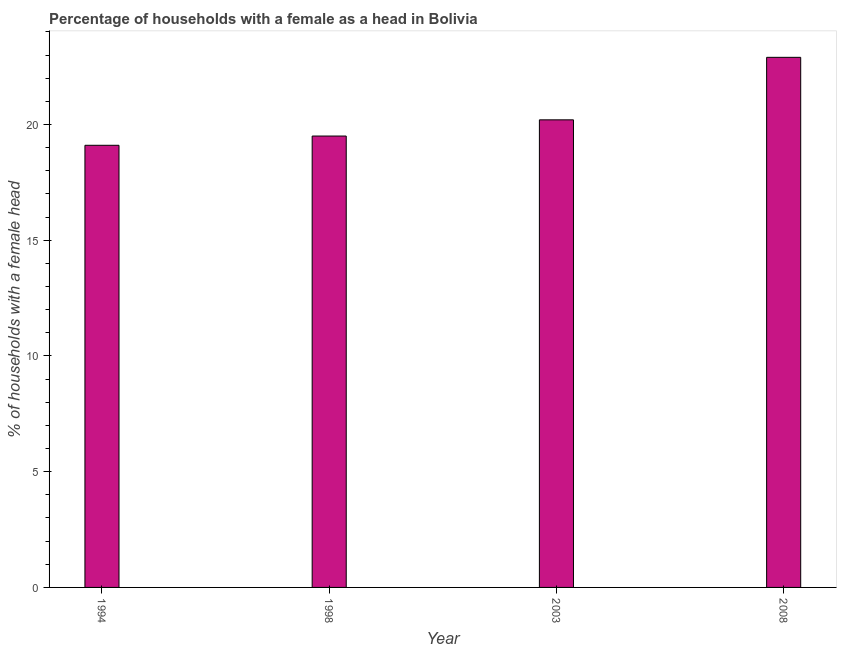Does the graph contain grids?
Keep it short and to the point. No. What is the title of the graph?
Your answer should be compact. Percentage of households with a female as a head in Bolivia. What is the label or title of the Y-axis?
Provide a succinct answer. % of households with a female head. What is the number of female supervised households in 2003?
Keep it short and to the point. 20.2. Across all years, what is the maximum number of female supervised households?
Offer a terse response. 22.9. Across all years, what is the minimum number of female supervised households?
Offer a terse response. 19.1. What is the sum of the number of female supervised households?
Your answer should be compact. 81.7. What is the average number of female supervised households per year?
Provide a short and direct response. 20.43. What is the median number of female supervised households?
Your answer should be compact. 19.85. Do a majority of the years between 2003 and 1994 (inclusive) have number of female supervised households greater than 18 %?
Provide a succinct answer. Yes. What is the ratio of the number of female supervised households in 1994 to that in 2003?
Provide a short and direct response. 0.95. Is the number of female supervised households in 1998 less than that in 2003?
Keep it short and to the point. Yes. Is the difference between the number of female supervised households in 2003 and 2008 greater than the difference between any two years?
Ensure brevity in your answer.  No. What is the difference between the highest and the second highest number of female supervised households?
Your answer should be compact. 2.7. What is the difference between the highest and the lowest number of female supervised households?
Make the answer very short. 3.8. How many bars are there?
Your answer should be compact. 4. Are all the bars in the graph horizontal?
Provide a succinct answer. No. What is the difference between two consecutive major ticks on the Y-axis?
Keep it short and to the point. 5. What is the % of households with a female head in 2003?
Your answer should be compact. 20.2. What is the % of households with a female head in 2008?
Provide a short and direct response. 22.9. What is the difference between the % of households with a female head in 1998 and 2003?
Provide a short and direct response. -0.7. What is the difference between the % of households with a female head in 1998 and 2008?
Ensure brevity in your answer.  -3.4. What is the ratio of the % of households with a female head in 1994 to that in 2003?
Provide a short and direct response. 0.95. What is the ratio of the % of households with a female head in 1994 to that in 2008?
Your answer should be compact. 0.83. What is the ratio of the % of households with a female head in 1998 to that in 2003?
Provide a short and direct response. 0.96. What is the ratio of the % of households with a female head in 1998 to that in 2008?
Ensure brevity in your answer.  0.85. What is the ratio of the % of households with a female head in 2003 to that in 2008?
Give a very brief answer. 0.88. 